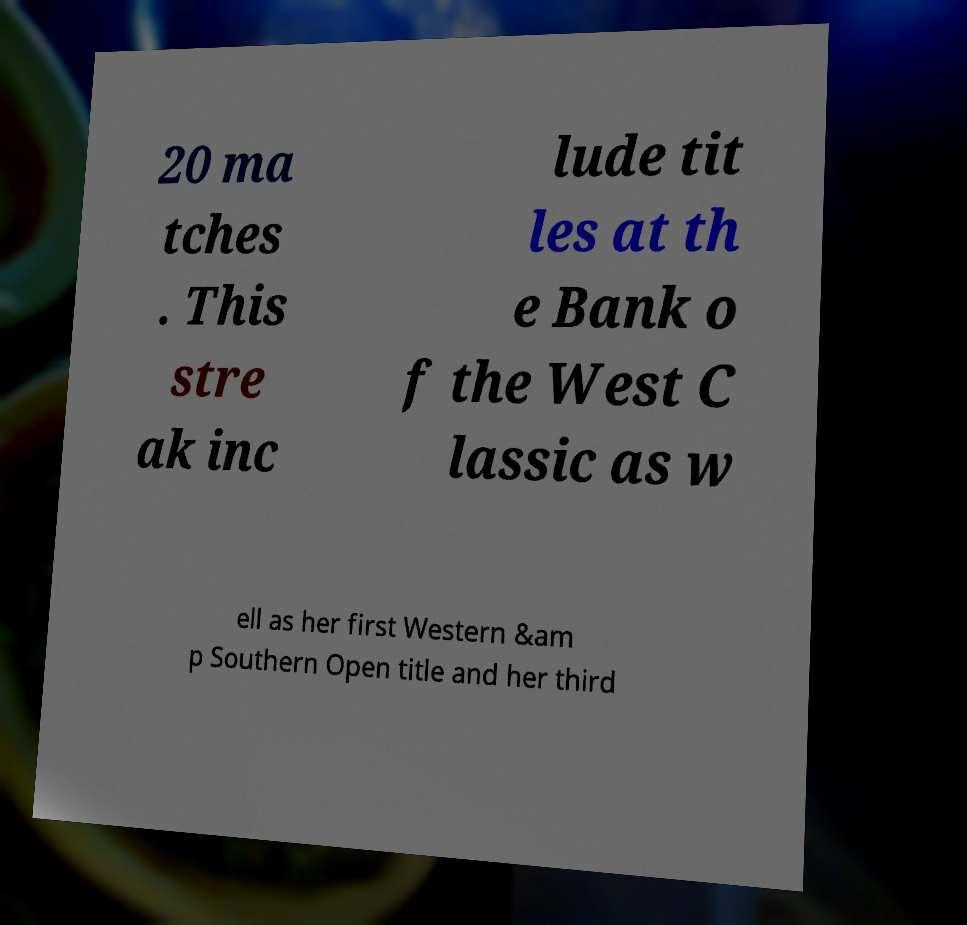What messages or text are displayed in this image? I need them in a readable, typed format. 20 ma tches . This stre ak inc lude tit les at th e Bank o f the West C lassic as w ell as her first Western &am p Southern Open title and her third 